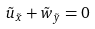<formula> <loc_0><loc_0><loc_500><loc_500>\tilde { u } _ { \tilde { x } } + \tilde { w } _ { \tilde { y } } = 0</formula> 